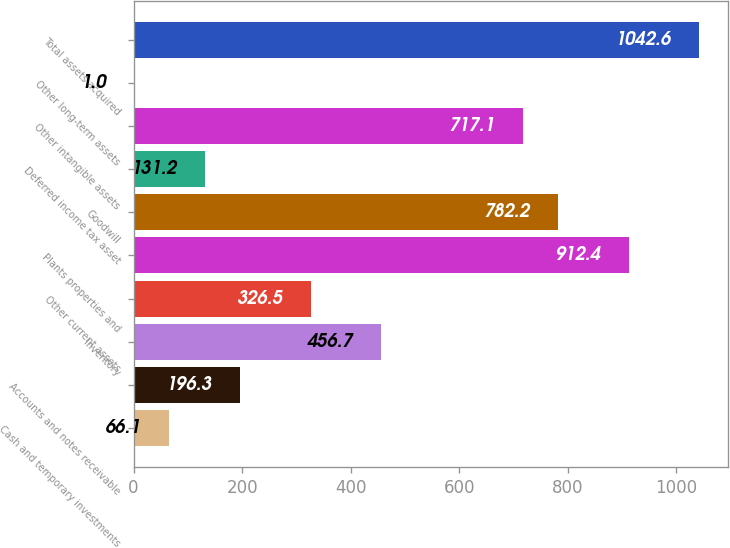<chart> <loc_0><loc_0><loc_500><loc_500><bar_chart><fcel>Cash and temporary investments<fcel>Accounts and notes receivable<fcel>Inventory<fcel>Other current assets<fcel>Plants properties and<fcel>Goodwill<fcel>Deferred income tax asset<fcel>Other intangible assets<fcel>Other long-term assets<fcel>Total assets acquired<nl><fcel>66.1<fcel>196.3<fcel>456.7<fcel>326.5<fcel>912.4<fcel>782.2<fcel>131.2<fcel>717.1<fcel>1<fcel>1042.6<nl></chart> 